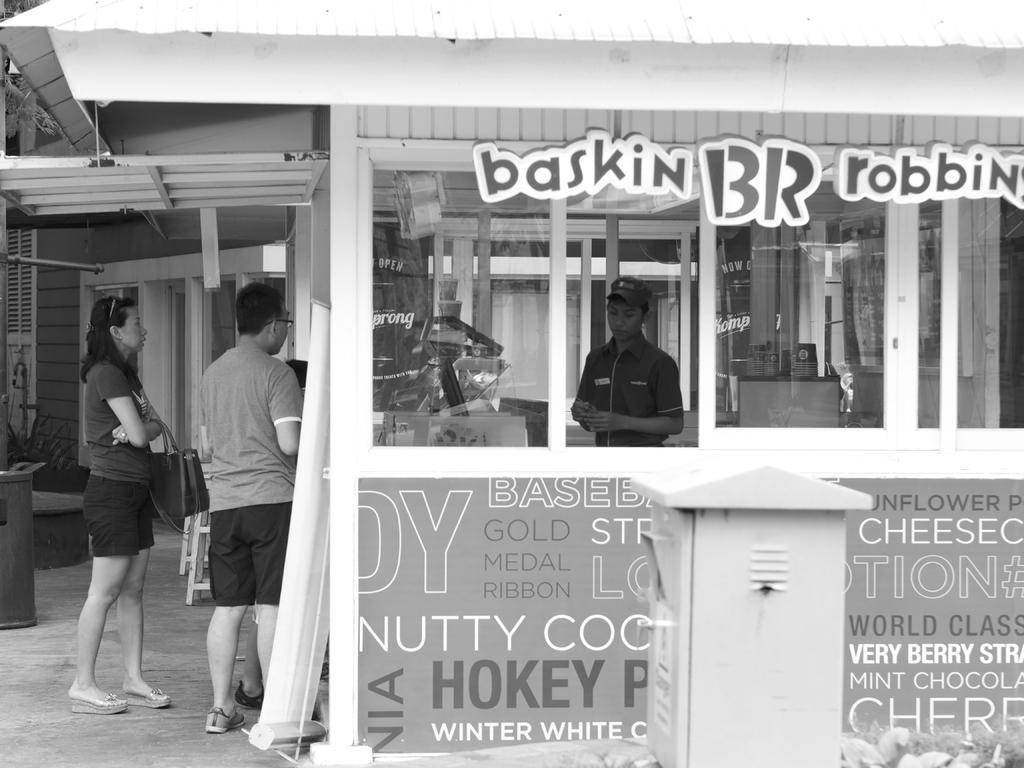What type of establishment is shown in the image? There is a shop in the image. Can you describe the people inside and outside the shop? There is a person standing inside the shop, and there are people standing outside the shop who are talking. What can be seen in the background of the image? There are walls visible in the background of the image. What type of ice can be seen melting in the shop? There is no ice present in the image, so it cannot be determined if any ice is melting. 